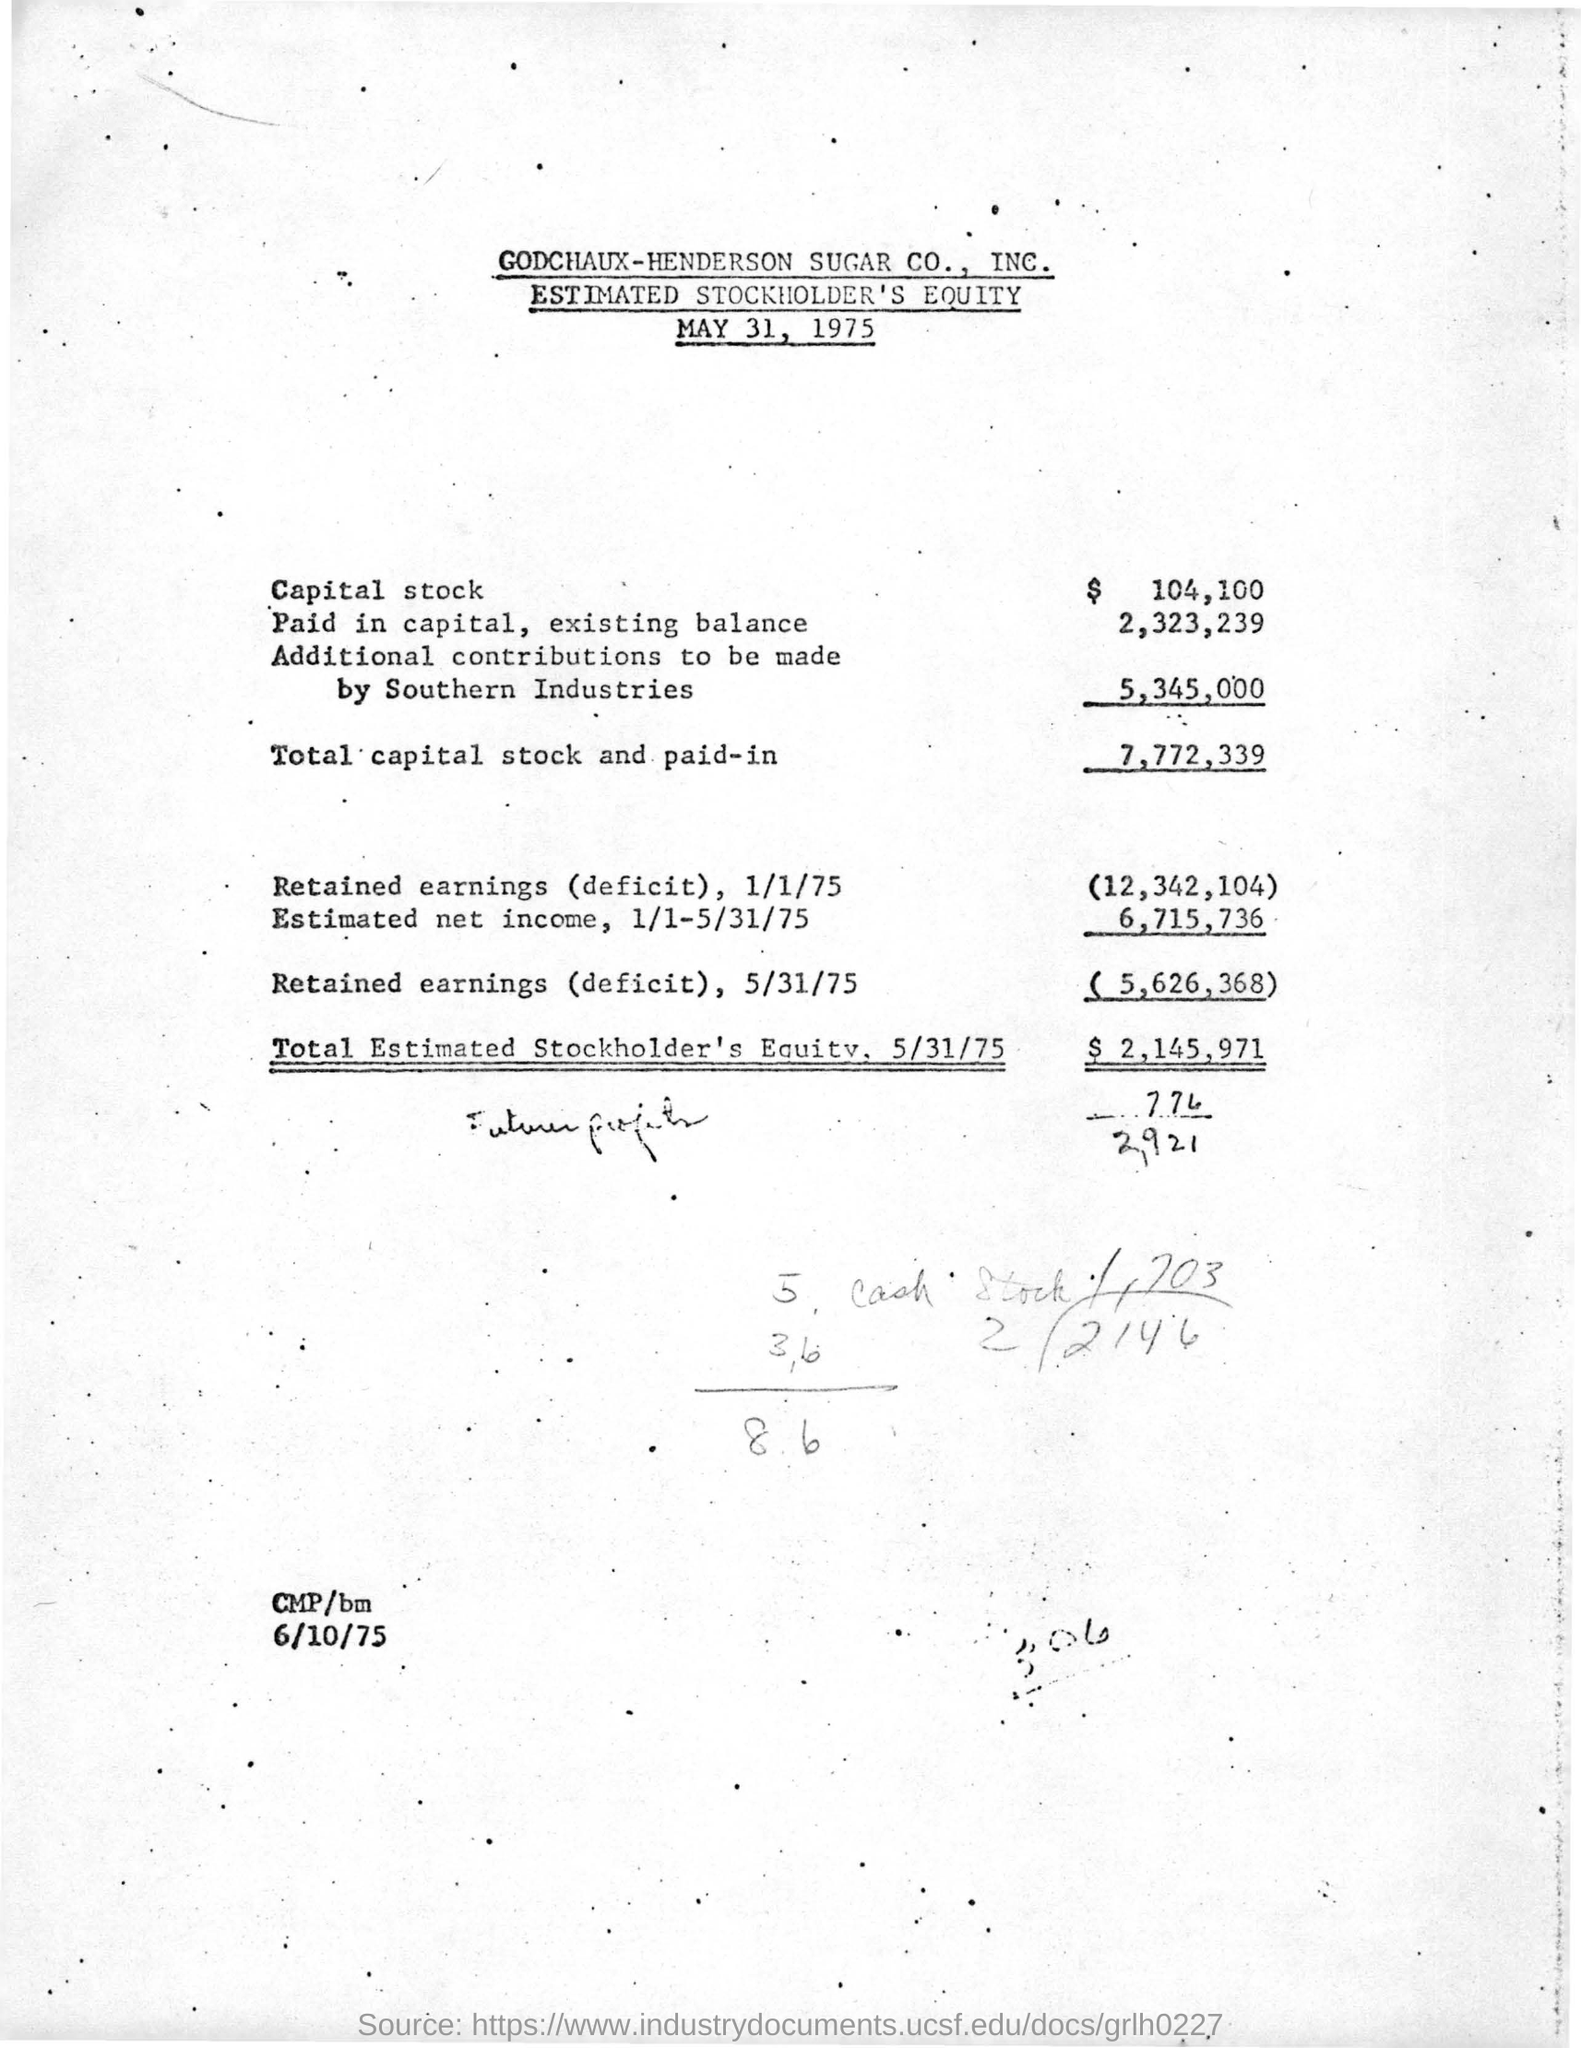List a handful of essential elements in this visual. The document was issued on May 31, 1975. This document is about estimating the stockholder's equity. The estimated net income for the period of January 1 to May 31, 1975 was approximately 6,715,736. As of May 31, 1975, the total estimated stockholder's equity was approximately $2,145,971. The total capital stock and paid-in amount is 7,772,339. 